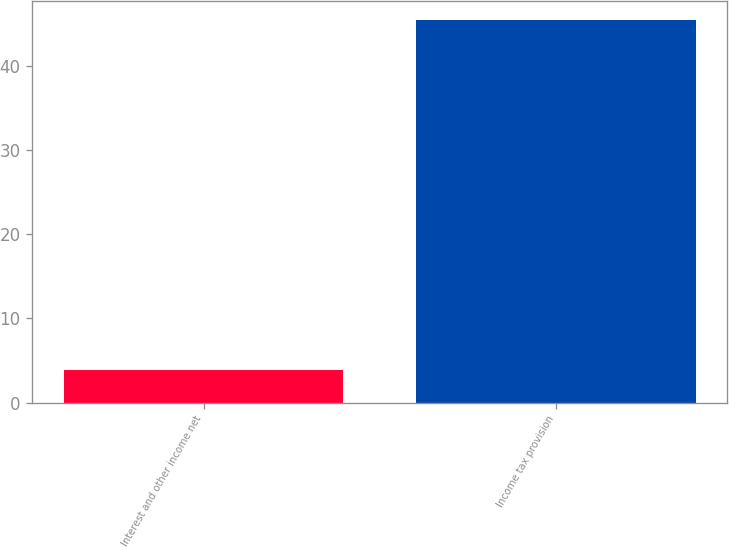<chart> <loc_0><loc_0><loc_500><loc_500><bar_chart><fcel>Interest and other income net<fcel>Income tax provision<nl><fcel>3.9<fcel>45.4<nl></chart> 